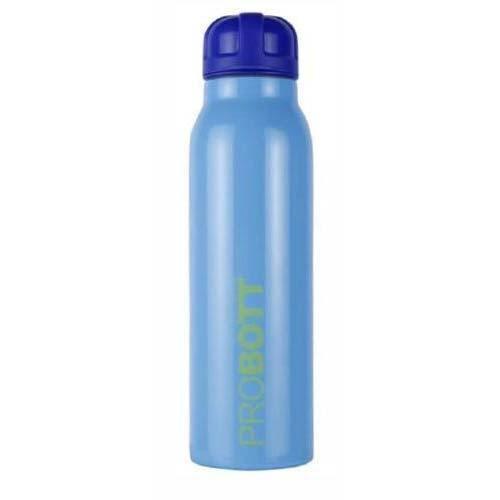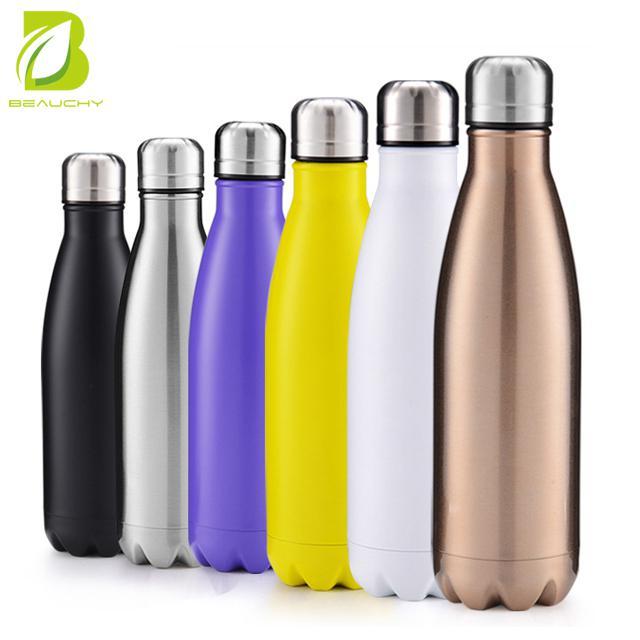The first image is the image on the left, the second image is the image on the right. For the images shown, is this caption "The left image include blue, lavender and purple water bottles, and the right image includes silver, red and blue bottles, as well as three 'loops' on bottles." true? Answer yes or no. No. The first image is the image on the left, the second image is the image on the right. Examine the images to the left and right. Is the description "The left and right image contains the same number of bottles." accurate? Answer yes or no. No. 